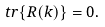Convert formula to latex. <formula><loc_0><loc_0><loc_500><loc_500>t r \{ R ( k ) \} = 0 .</formula> 